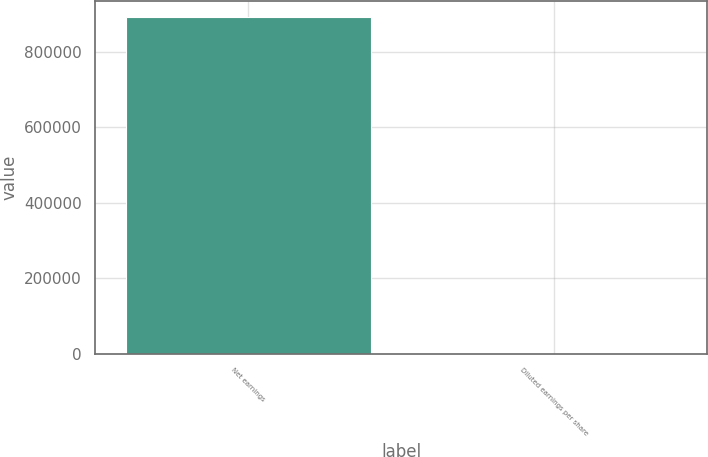Convert chart. <chart><loc_0><loc_0><loc_500><loc_500><bar_chart><fcel>Net earnings<fcel>Diluted earnings per share<nl><fcel>890052<fcel>1.64<nl></chart> 